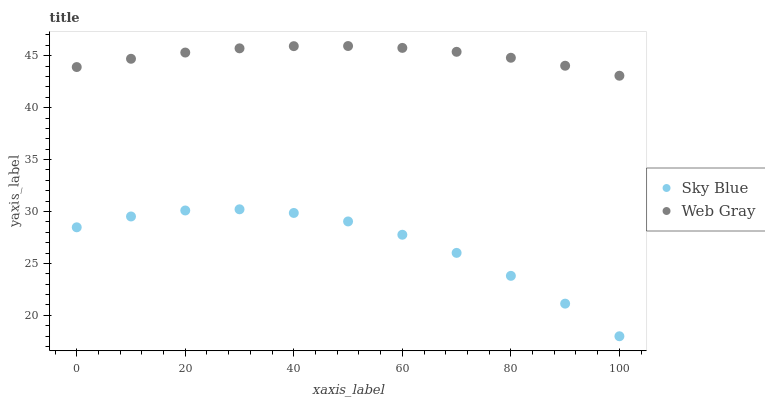Does Sky Blue have the minimum area under the curve?
Answer yes or no. Yes. Does Web Gray have the maximum area under the curve?
Answer yes or no. Yes. Does Web Gray have the minimum area under the curve?
Answer yes or no. No. Is Web Gray the smoothest?
Answer yes or no. Yes. Is Sky Blue the roughest?
Answer yes or no. Yes. Is Web Gray the roughest?
Answer yes or no. No. Does Sky Blue have the lowest value?
Answer yes or no. Yes. Does Web Gray have the lowest value?
Answer yes or no. No. Does Web Gray have the highest value?
Answer yes or no. Yes. Is Sky Blue less than Web Gray?
Answer yes or no. Yes. Is Web Gray greater than Sky Blue?
Answer yes or no. Yes. Does Sky Blue intersect Web Gray?
Answer yes or no. No. 